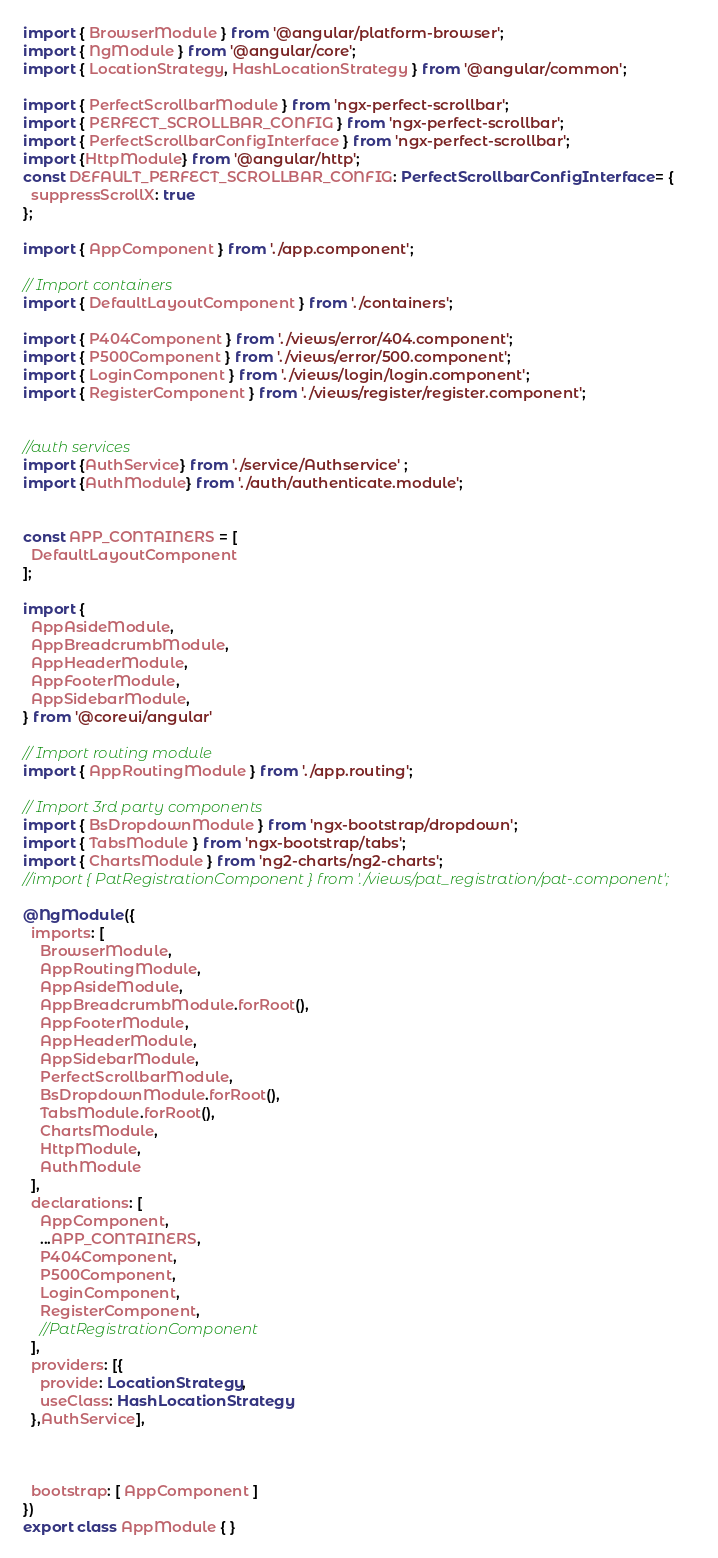<code> <loc_0><loc_0><loc_500><loc_500><_TypeScript_>import { BrowserModule } from '@angular/platform-browser';
import { NgModule } from '@angular/core';
import { LocationStrategy, HashLocationStrategy } from '@angular/common';

import { PerfectScrollbarModule } from 'ngx-perfect-scrollbar';
import { PERFECT_SCROLLBAR_CONFIG } from 'ngx-perfect-scrollbar';
import { PerfectScrollbarConfigInterface } from 'ngx-perfect-scrollbar';
import {HttpModule} from '@angular/http';
const DEFAULT_PERFECT_SCROLLBAR_CONFIG: PerfectScrollbarConfigInterface = {
  suppressScrollX: true
};

import { AppComponent } from './app.component';

// Import containers
import { DefaultLayoutComponent } from './containers';

import { P404Component } from './views/error/404.component';
import { P500Component } from './views/error/500.component';
import { LoginComponent } from './views/login/login.component';
import { RegisterComponent } from './views/register/register.component';


//auth services
import {AuthService} from './service/Authservice' ;
import {AuthModule} from './auth/authenticate.module';


const APP_CONTAINERS = [
  DefaultLayoutComponent
];

import {
  AppAsideModule,
  AppBreadcrumbModule,
  AppHeaderModule,
  AppFooterModule,
  AppSidebarModule,
} from '@coreui/angular'

// Import routing module
import { AppRoutingModule } from './app.routing';

// Import 3rd party components
import { BsDropdownModule } from 'ngx-bootstrap/dropdown';
import { TabsModule } from 'ngx-bootstrap/tabs';
import { ChartsModule } from 'ng2-charts/ng2-charts';
//import { PatRegistrationComponent } from './views/pat_registration/pat-.component';

@NgModule({
  imports: [
    BrowserModule,
    AppRoutingModule,
    AppAsideModule,
    AppBreadcrumbModule.forRoot(),
    AppFooterModule,
    AppHeaderModule,
    AppSidebarModule,
    PerfectScrollbarModule,
    BsDropdownModule.forRoot(),
    TabsModule.forRoot(),
    ChartsModule,
    HttpModule,
    AuthModule
  ],
  declarations: [
    AppComponent,
    ...APP_CONTAINERS,
    P404Component,
    P500Component,
    LoginComponent,
    RegisterComponent,
    //PatRegistrationComponent
  ],
  providers: [{
    provide: LocationStrategy,
    useClass: HashLocationStrategy
  },AuthService],



  bootstrap: [ AppComponent ]
})
export class AppModule { }
</code> 